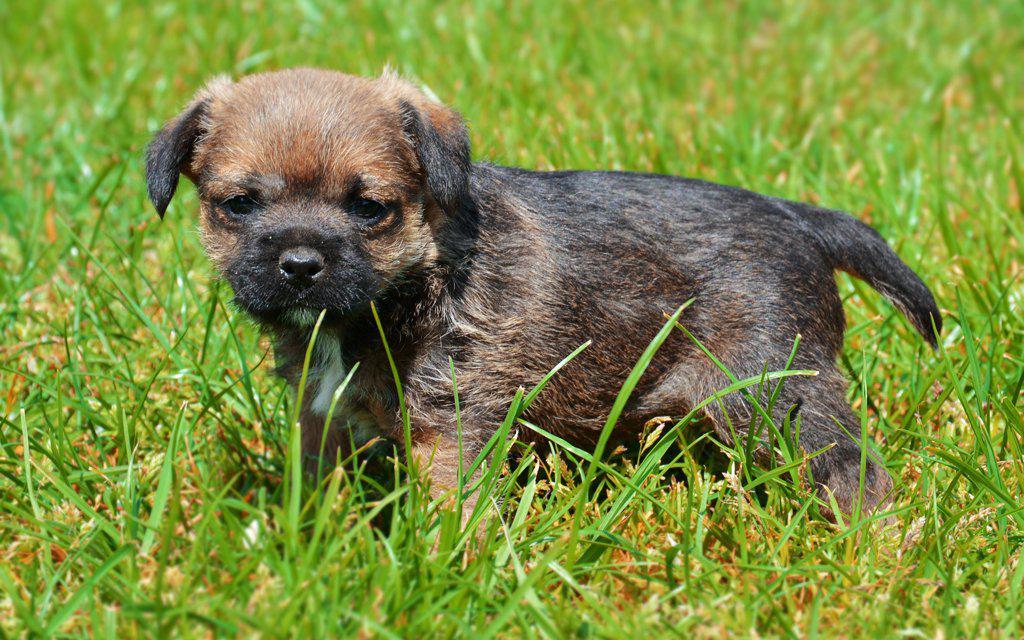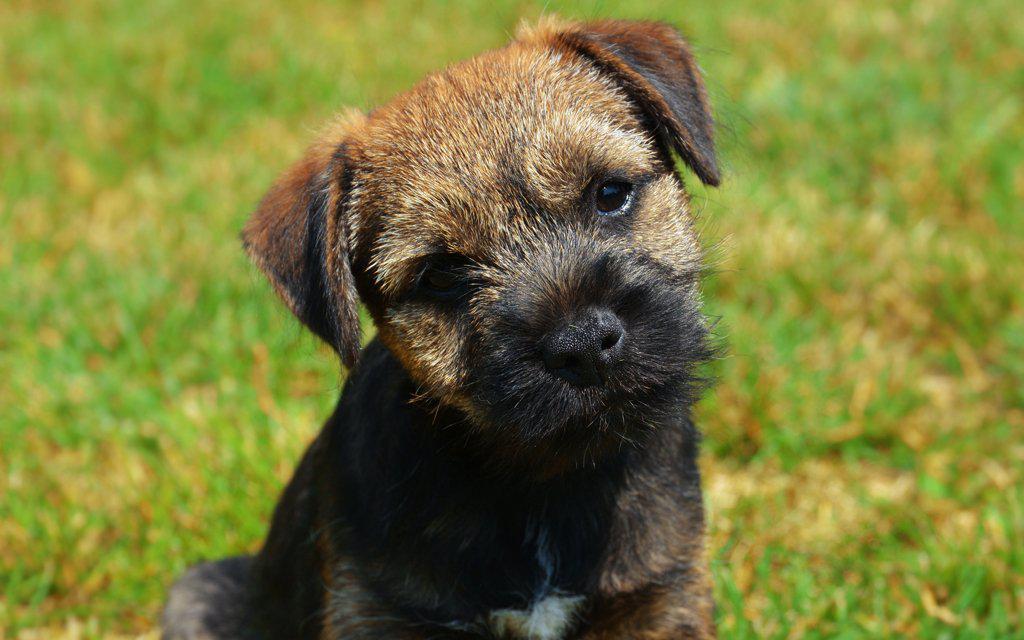The first image is the image on the left, the second image is the image on the right. For the images displayed, is the sentence "There are two dogs" factually correct? Answer yes or no. Yes. The first image is the image on the left, the second image is the image on the right. For the images shown, is this caption "Exactly two small dogs are shown in an outdoor field setting." true? Answer yes or no. Yes. 